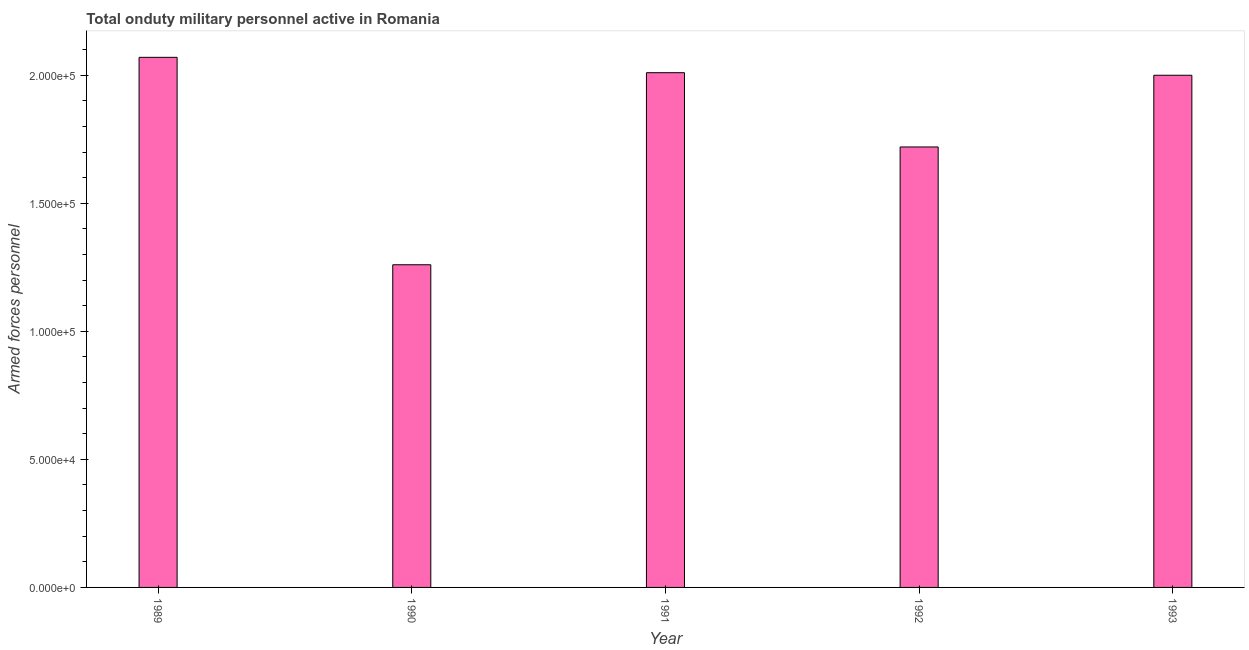Does the graph contain grids?
Offer a very short reply. No. What is the title of the graph?
Provide a succinct answer. Total onduty military personnel active in Romania. What is the label or title of the Y-axis?
Offer a very short reply. Armed forces personnel. What is the number of armed forces personnel in 1992?
Your answer should be very brief. 1.72e+05. Across all years, what is the maximum number of armed forces personnel?
Provide a succinct answer. 2.07e+05. Across all years, what is the minimum number of armed forces personnel?
Your answer should be compact. 1.26e+05. In which year was the number of armed forces personnel maximum?
Ensure brevity in your answer.  1989. In which year was the number of armed forces personnel minimum?
Make the answer very short. 1990. What is the sum of the number of armed forces personnel?
Ensure brevity in your answer.  9.06e+05. What is the difference between the number of armed forces personnel in 1989 and 1991?
Offer a very short reply. 6000. What is the average number of armed forces personnel per year?
Provide a succinct answer. 1.81e+05. In how many years, is the number of armed forces personnel greater than 190000 ?
Your answer should be compact. 3. Do a majority of the years between 1993 and 1989 (inclusive) have number of armed forces personnel greater than 120000 ?
Keep it short and to the point. Yes. Is the number of armed forces personnel in 1990 less than that in 1991?
Provide a short and direct response. Yes. Is the difference between the number of armed forces personnel in 1989 and 1993 greater than the difference between any two years?
Ensure brevity in your answer.  No. What is the difference between the highest and the second highest number of armed forces personnel?
Make the answer very short. 6000. Is the sum of the number of armed forces personnel in 1990 and 1991 greater than the maximum number of armed forces personnel across all years?
Make the answer very short. Yes. What is the difference between the highest and the lowest number of armed forces personnel?
Provide a succinct answer. 8.10e+04. In how many years, is the number of armed forces personnel greater than the average number of armed forces personnel taken over all years?
Give a very brief answer. 3. How many bars are there?
Keep it short and to the point. 5. Are all the bars in the graph horizontal?
Your answer should be compact. No. How many years are there in the graph?
Make the answer very short. 5. Are the values on the major ticks of Y-axis written in scientific E-notation?
Your answer should be very brief. Yes. What is the Armed forces personnel of 1989?
Offer a very short reply. 2.07e+05. What is the Armed forces personnel of 1990?
Your response must be concise. 1.26e+05. What is the Armed forces personnel of 1991?
Provide a succinct answer. 2.01e+05. What is the Armed forces personnel of 1992?
Ensure brevity in your answer.  1.72e+05. What is the difference between the Armed forces personnel in 1989 and 1990?
Ensure brevity in your answer.  8.10e+04. What is the difference between the Armed forces personnel in 1989 and 1991?
Provide a succinct answer. 6000. What is the difference between the Armed forces personnel in 1989 and 1992?
Keep it short and to the point. 3.50e+04. What is the difference between the Armed forces personnel in 1989 and 1993?
Provide a short and direct response. 7000. What is the difference between the Armed forces personnel in 1990 and 1991?
Ensure brevity in your answer.  -7.50e+04. What is the difference between the Armed forces personnel in 1990 and 1992?
Your answer should be compact. -4.60e+04. What is the difference between the Armed forces personnel in 1990 and 1993?
Your response must be concise. -7.40e+04. What is the difference between the Armed forces personnel in 1991 and 1992?
Give a very brief answer. 2.90e+04. What is the difference between the Armed forces personnel in 1991 and 1993?
Make the answer very short. 1000. What is the difference between the Armed forces personnel in 1992 and 1993?
Keep it short and to the point. -2.80e+04. What is the ratio of the Armed forces personnel in 1989 to that in 1990?
Give a very brief answer. 1.64. What is the ratio of the Armed forces personnel in 1989 to that in 1992?
Give a very brief answer. 1.2. What is the ratio of the Armed forces personnel in 1989 to that in 1993?
Make the answer very short. 1.03. What is the ratio of the Armed forces personnel in 1990 to that in 1991?
Give a very brief answer. 0.63. What is the ratio of the Armed forces personnel in 1990 to that in 1992?
Your answer should be very brief. 0.73. What is the ratio of the Armed forces personnel in 1990 to that in 1993?
Offer a terse response. 0.63. What is the ratio of the Armed forces personnel in 1991 to that in 1992?
Provide a succinct answer. 1.17. What is the ratio of the Armed forces personnel in 1992 to that in 1993?
Keep it short and to the point. 0.86. 